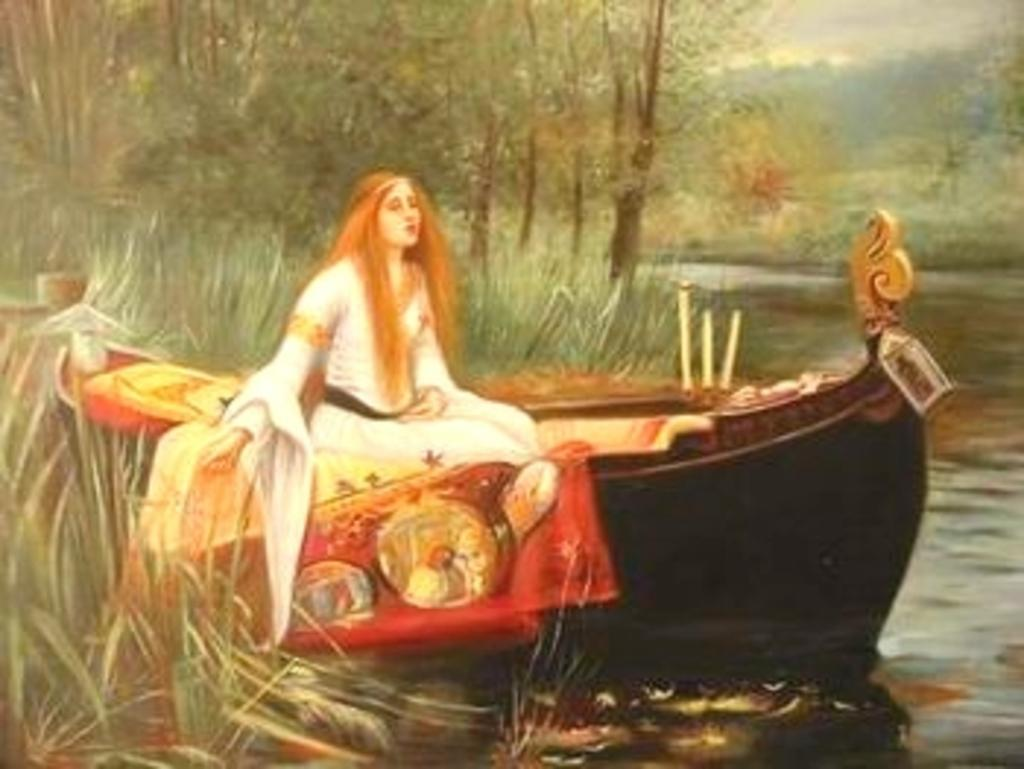What type of artwork is depicted in the image? The image is a painting. Who or what is the main subject of the painting? There is a woman in the painting. What is the woman doing in the painting? The woman is sitting on a boat. What is the woman wearing in the painting? The woman is wearing a white dress. What can be seen in the background of the painting? There is water and trees in the painting. What type of wine is the woman holding in the painting? There is no wine present in the painting; the woman is sitting on a boat and wearing a white dress. How many flowers can be seen in the painting? There are no flowers depicted in the painting; it features a woman sitting on a boat in a white dress, with water and trees in the background. 